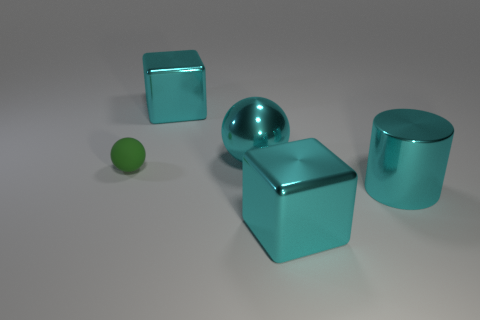Is the number of big metal objects to the left of the tiny object the same as the number of big metal blocks that are in front of the metal cylinder?
Make the answer very short. No. What material is the cyan cylinder?
Your response must be concise. Metal. There is a cube right of the cyan ball; what is its material?
Provide a short and direct response. Metal. Is there anything else that has the same material as the small ball?
Your answer should be very brief. No. Is the number of cubes that are behind the tiny green rubber object greater than the number of brown blocks?
Your response must be concise. Yes. Are there any large cyan shiny things to the left of the metallic cube that is behind the large cube that is on the right side of the cyan ball?
Your answer should be very brief. No. Are there any big metallic things in front of the small green rubber object?
Give a very brief answer. Yes. What number of metallic things have the same color as the big cylinder?
Give a very brief answer. 3. There is a cyan cube left of the large cyan sphere on the left side of the cube in front of the green object; what size is it?
Your response must be concise. Large. There is a ball that is on the right side of the small matte ball; what is its size?
Offer a very short reply. Large. 